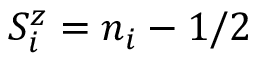<formula> <loc_0><loc_0><loc_500><loc_500>S _ { i } ^ { z } = n _ { i } - 1 / 2</formula> 